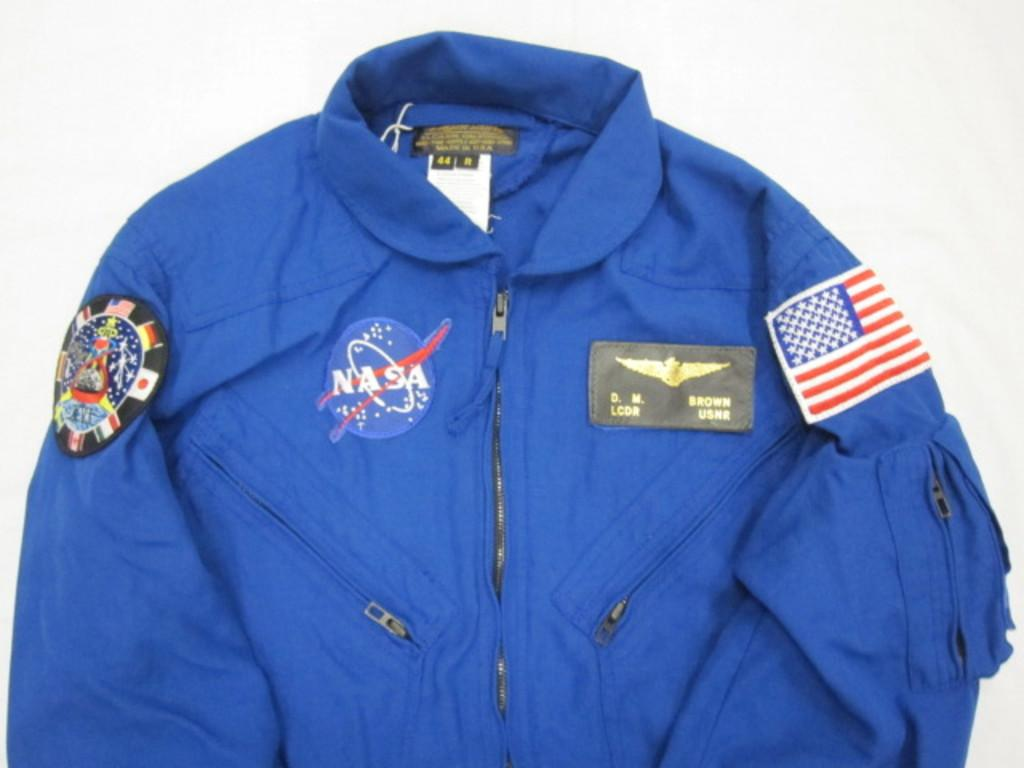<image>
Relay a brief, clear account of the picture shown. A Nasa emblem is on a blue jacket with other badges. 